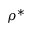Convert formula to latex. <formula><loc_0><loc_0><loc_500><loc_500>\rho ^ { * }</formula> 